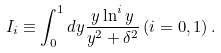<formula> <loc_0><loc_0><loc_500><loc_500>I _ { i } \equiv \int _ { 0 } ^ { 1 } d y \frac { y \ln ^ { i } y } { y ^ { 2 } + \delta ^ { 2 } } \, ( i = 0 , 1 ) \, .</formula> 